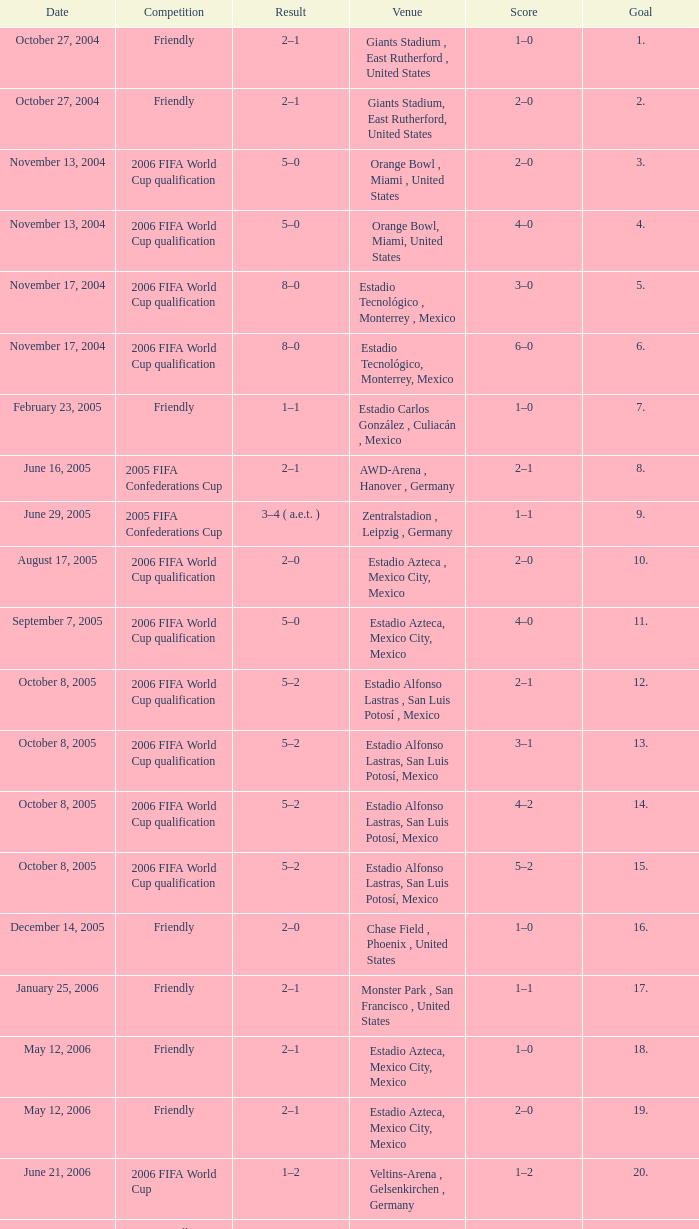Could you parse the entire table as a dict? {'header': ['Date', 'Competition', 'Result', 'Venue', 'Score', 'Goal'], 'rows': [['October 27, 2004', 'Friendly', '2–1', 'Giants Stadium , East Rutherford , United States', '1–0', '1.'], ['October 27, 2004', 'Friendly', '2–1', 'Giants Stadium, East Rutherford, United States', '2–0', '2.'], ['November 13, 2004', '2006 FIFA World Cup qualification', '5–0', 'Orange Bowl , Miami , United States', '2–0', '3.'], ['November 13, 2004', '2006 FIFA World Cup qualification', '5–0', 'Orange Bowl, Miami, United States', '4–0', '4.'], ['November 17, 2004', '2006 FIFA World Cup qualification', '8–0', 'Estadio Tecnológico , Monterrey , Mexico', '3–0', '5.'], ['November 17, 2004', '2006 FIFA World Cup qualification', '8–0', 'Estadio Tecnológico, Monterrey, Mexico', '6–0', '6.'], ['February 23, 2005', 'Friendly', '1–1', 'Estadio Carlos González , Culiacán , Mexico', '1–0', '7.'], ['June 16, 2005', '2005 FIFA Confederations Cup', '2–1', 'AWD-Arena , Hanover , Germany', '2–1', '8.'], ['June 29, 2005', '2005 FIFA Confederations Cup', '3–4 ( a.e.t. )', 'Zentralstadion , Leipzig , Germany', '1–1', '9.'], ['August 17, 2005', '2006 FIFA World Cup qualification', '2–0', 'Estadio Azteca , Mexico City, Mexico', '2–0', '10.'], ['September 7, 2005', '2006 FIFA World Cup qualification', '5–0', 'Estadio Azteca, Mexico City, Mexico', '4–0', '11.'], ['October 8, 2005', '2006 FIFA World Cup qualification', '5–2', 'Estadio Alfonso Lastras , San Luis Potosí , Mexico', '2–1', '12.'], ['October 8, 2005', '2006 FIFA World Cup qualification', '5–2', 'Estadio Alfonso Lastras, San Luis Potosí, Mexico', '3–1', '13.'], ['October 8, 2005', '2006 FIFA World Cup qualification', '5–2', 'Estadio Alfonso Lastras, San Luis Potosí, Mexico', '4–2', '14.'], ['October 8, 2005', '2006 FIFA World Cup qualification', '5–2', 'Estadio Alfonso Lastras, San Luis Potosí, Mexico', '5–2', '15.'], ['December 14, 2005', 'Friendly', '2–0', 'Chase Field , Phoenix , United States', '1–0', '16.'], ['January 25, 2006', 'Friendly', '2–1', 'Monster Park , San Francisco , United States', '1–1', '17.'], ['May 12, 2006', 'Friendly', '2–1', 'Estadio Azteca, Mexico City, Mexico', '1–0', '18.'], ['May 12, 2006', 'Friendly', '2–1', 'Estadio Azteca, Mexico City, Mexico', '2–0', '19.'], ['June 21, 2006', '2006 FIFA World Cup', '1–2', 'Veltins-Arena , Gelsenkirchen , Germany', '1–2', '20.'], ['June 2, 2007', 'Friendly', '4–0', 'Estadio Alfonso Lastras, San Luis Potosí, Mexico', '3–0', '21.']]} Which Result has a Score of 1–0, and a Goal of 16? 2–0. 